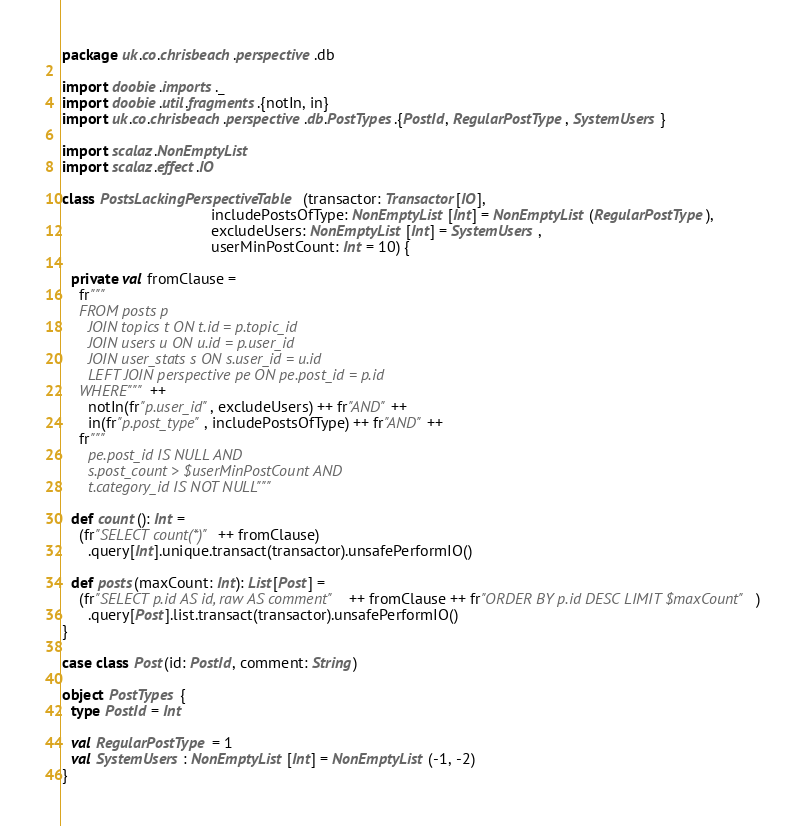<code> <loc_0><loc_0><loc_500><loc_500><_Scala_>package uk.co.chrisbeach.perspective.db

import doobie.imports._
import doobie.util.fragments.{notIn, in}
import uk.co.chrisbeach.perspective.db.PostTypes.{PostId, RegularPostType, SystemUsers}

import scalaz.NonEmptyList
import scalaz.effect.IO

class PostsLackingPerspectiveTable(transactor: Transactor[IO],
                                   includePostsOfType: NonEmptyList[Int] = NonEmptyList(RegularPostType),
                                   excludeUsers: NonEmptyList[Int] = SystemUsers,
                                   userMinPostCount: Int = 10) {

  private val fromClause =
    fr"""
    FROM posts p
      JOIN topics t ON t.id = p.topic_id
      JOIN users u ON u.id = p.user_id
      JOIN user_stats s ON s.user_id = u.id
      LEFT JOIN perspective pe ON pe.post_id = p.id
    WHERE""" ++
      notIn(fr"p.user_id", excludeUsers) ++ fr"AND" ++
      in(fr"p.post_type", includePostsOfType) ++ fr"AND" ++
    fr"""
      pe.post_id IS NULL AND
      s.post_count > $userMinPostCount AND
      t.category_id IS NOT NULL"""

  def count(): Int =
    (fr"SELECT count(*)" ++ fromClause)
      .query[Int].unique.transact(transactor).unsafePerformIO()

  def posts(maxCount: Int): List[Post] =
    (fr"SELECT p.id AS id, raw AS comment" ++ fromClause ++ fr"ORDER BY p.id DESC LIMIT $maxCount")
      .query[Post].list.transact(transactor).unsafePerformIO()
}

case class Post(id: PostId, comment: String)

object PostTypes {
  type PostId = Int

  val RegularPostType = 1
  val SystemUsers: NonEmptyList[Int] = NonEmptyList(-1, -2)
}</code> 